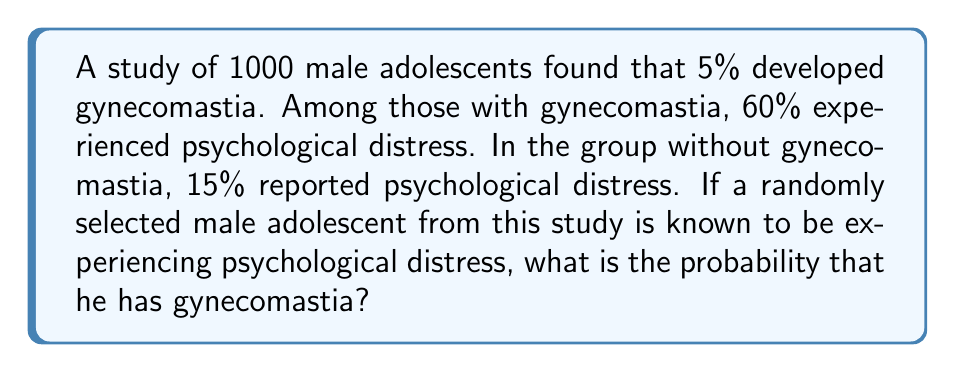Solve this math problem. Let's approach this problem using Bayes' Theorem. We'll define the following events:
G: The adolescent has gynecomastia
D: The adolescent experiences psychological distress

We're given the following probabilities:
$P(G) = 0.05$ (5% of adolescents have gynecomastia)
$P(D|G) = 0.60$ (60% of those with gynecomastia experience distress)
$P(D|\text{not }G) = 0.15$ (15% of those without gynecomastia experience distress)

We want to find $P(G|D)$, which can be calculated using Bayes' Theorem:

$$P(G|D) = \frac{P(D|G) \cdot P(G)}{P(D)}$$

We need to calculate $P(D)$ using the law of total probability:

$$P(D) = P(D|G) \cdot P(G) + P(D|\text{not }G) \cdot P(\text{not }G)$$

$P(\text{not }G) = 1 - P(G) = 1 - 0.05 = 0.95$

Now, let's substitute the values:

$$P(D) = 0.60 \cdot 0.05 + 0.15 \cdot 0.95 = 0.03 + 0.1425 = 0.1725$$

Now we can apply Bayes' Theorem:

$$P(G|D) = \frac{0.60 \cdot 0.05}{0.1725} = \frac{0.03}{0.1725} \approx 0.1739$$
Answer: The probability that a male adolescent experiencing psychological distress has gynecomastia is approximately 0.1739 or 17.39%. 